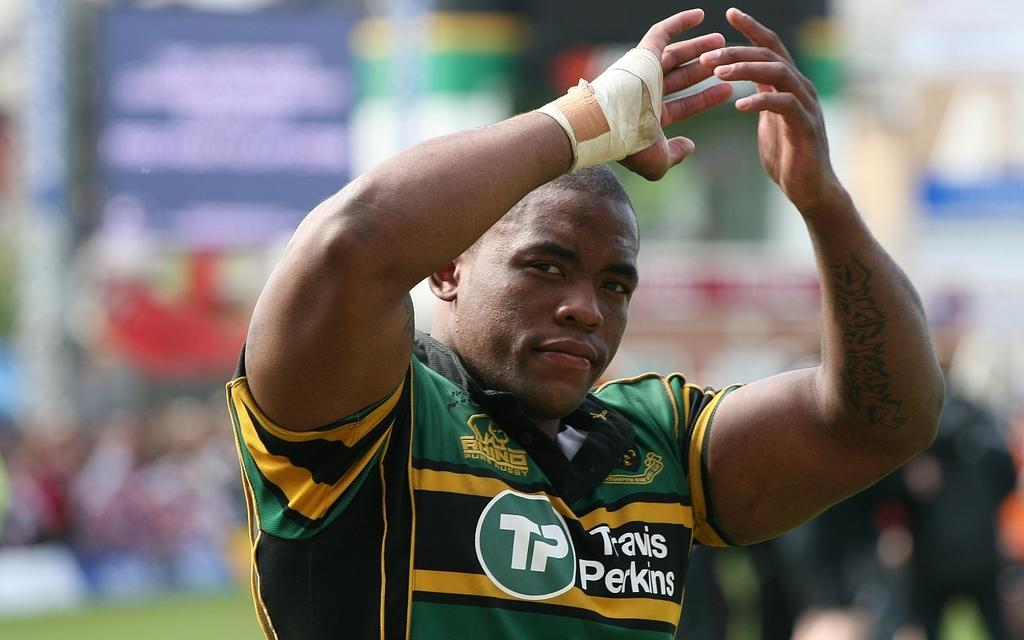<image>
Provide a brief description of the given image. a player with the letters TP on it 